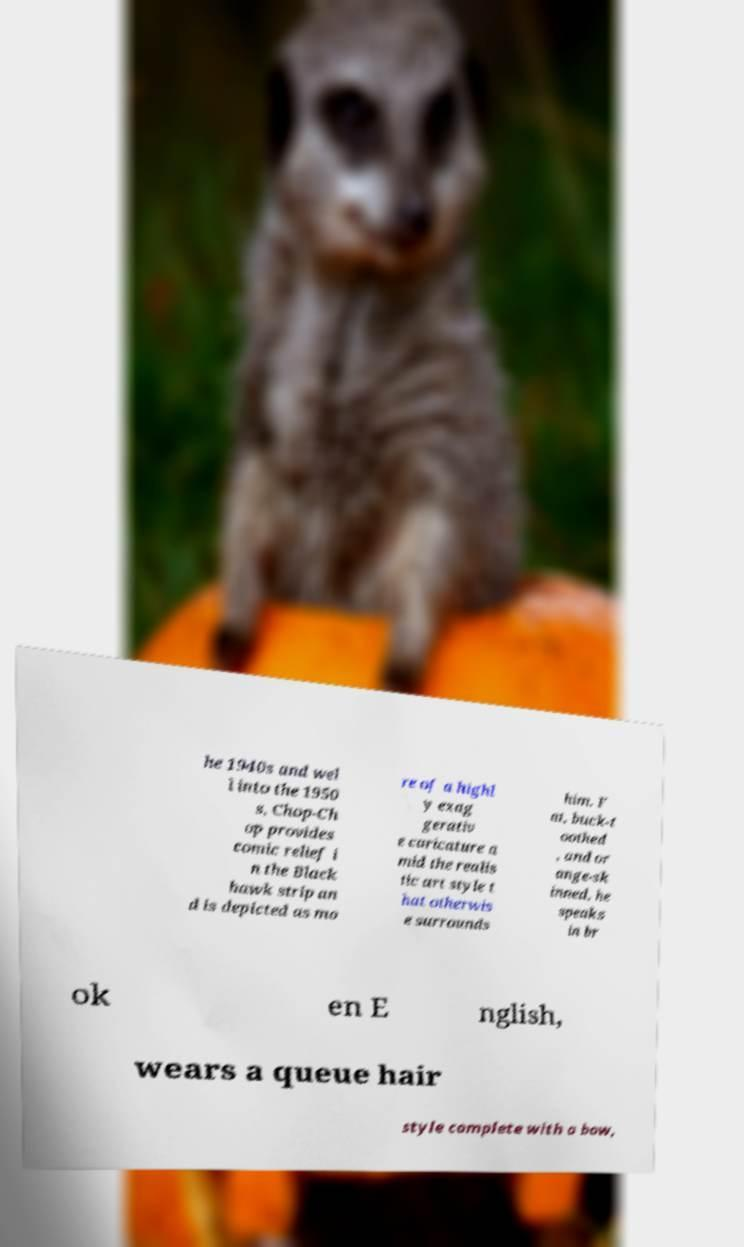I need the written content from this picture converted into text. Can you do that? he 1940s and wel l into the 1950 s, Chop-Ch op provides comic relief i n the Black hawk strip an d is depicted as mo re of a highl y exag gerativ e caricature a mid the realis tic art style t hat otherwis e surrounds him. F at, buck-t oothed , and or ange-sk inned, he speaks in br ok en E nglish, wears a queue hair style complete with a bow, 